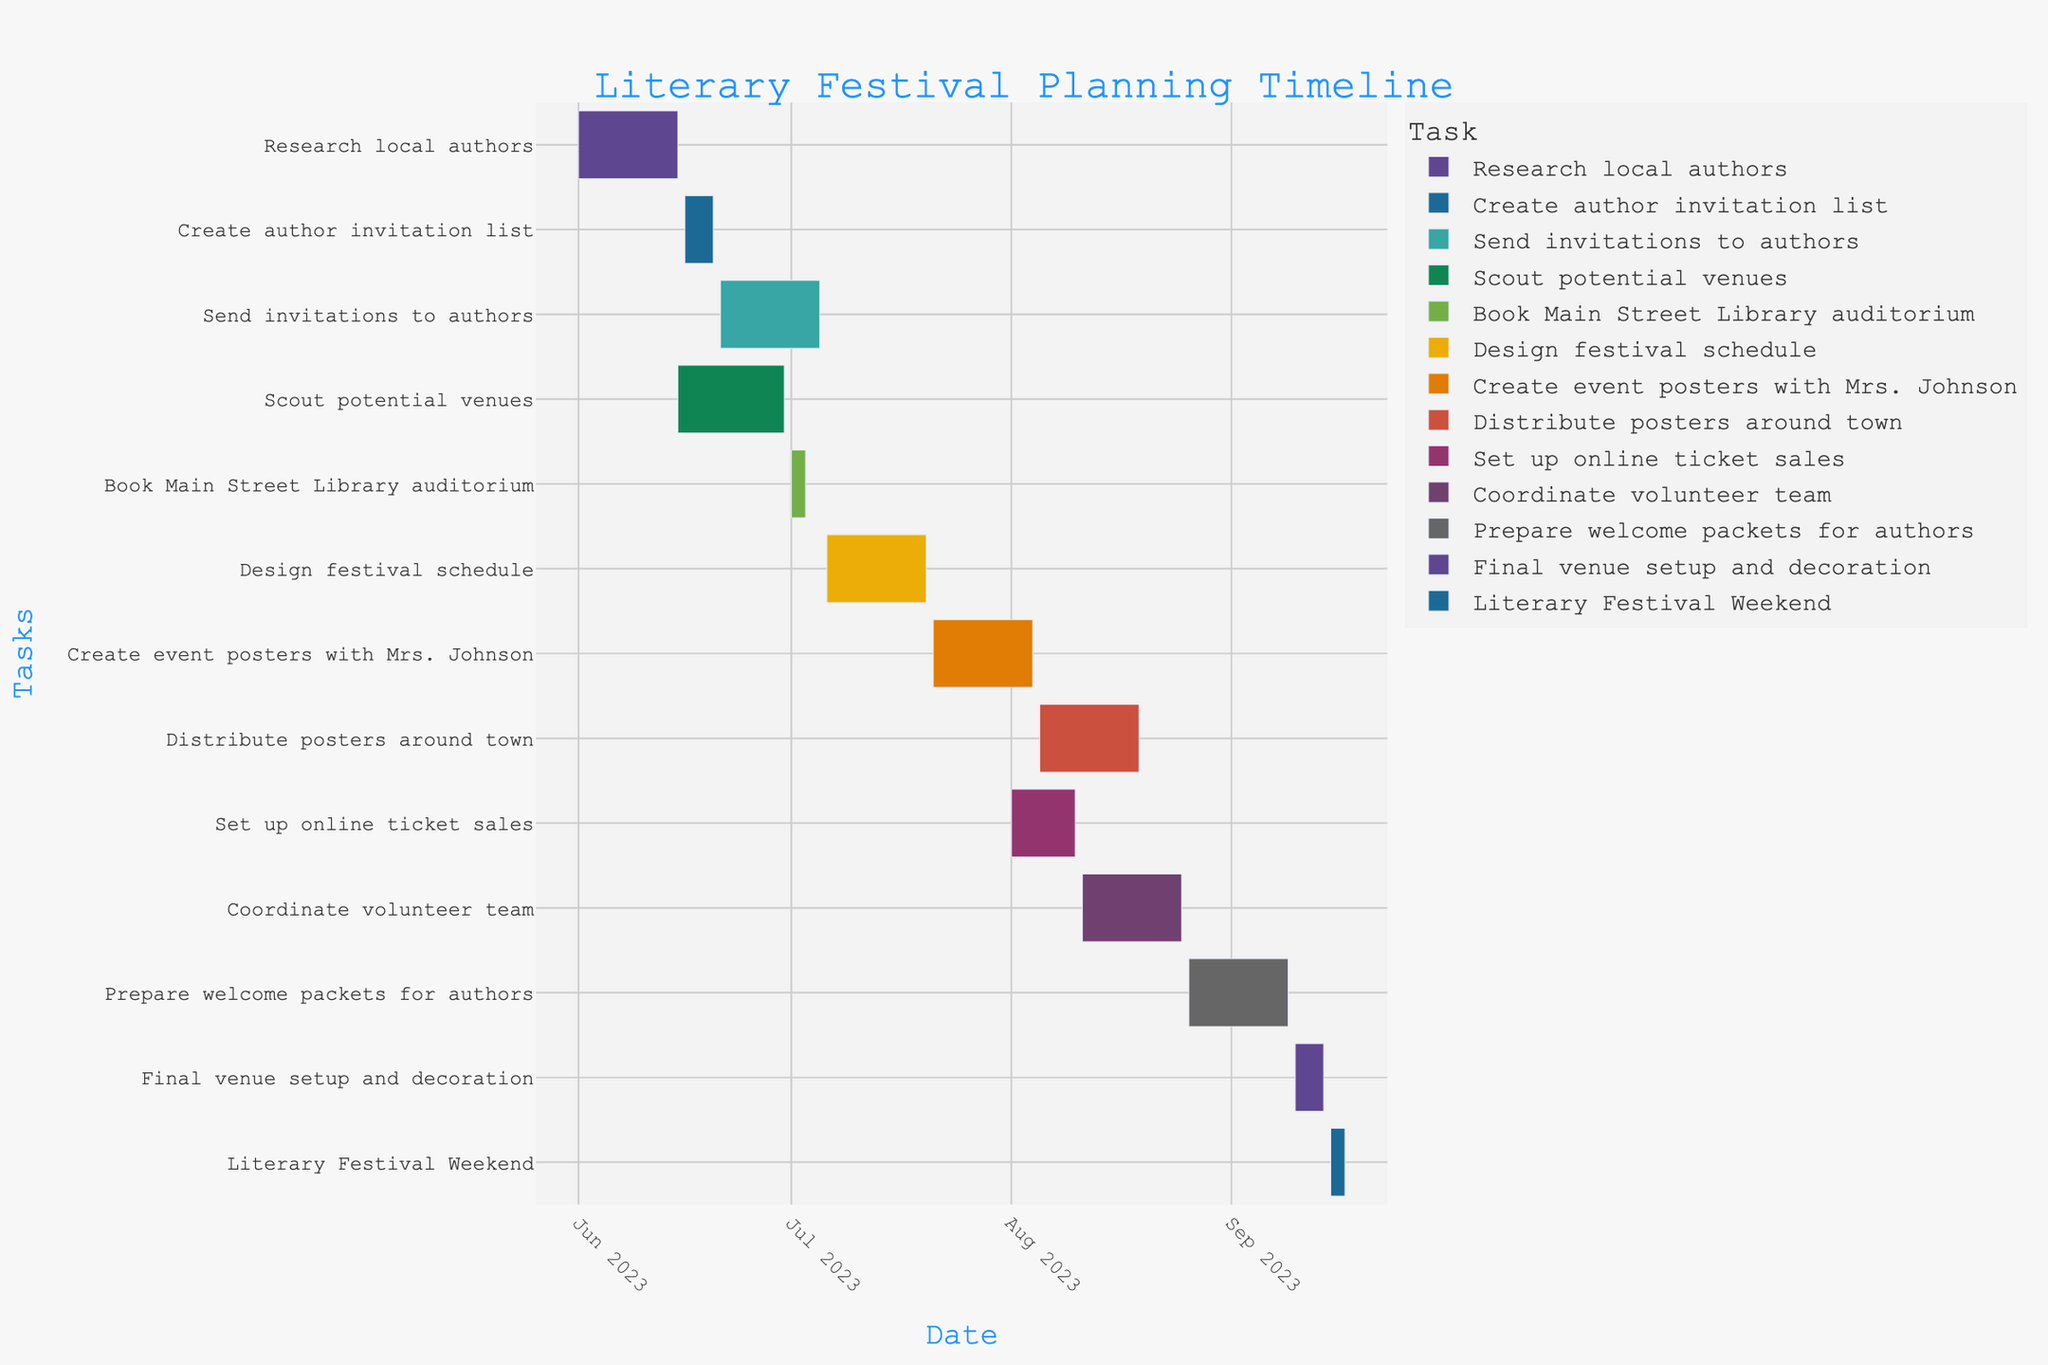What is the title of the chart? The title is usually displayed prominently at the top of the chart. In this case, the title is "Literary Festival Planning Timeline."
Answer: Literary Festival Planning Timeline What are the start and end dates for the "Book Main Street Library auditorium" task? Check the horizontal bars corresponding to the task "Book Main Street Library auditorium." Note the start and end dates next to the bar.
Answer: July 1, 2023 to July 3, 2023 Which task has the longest duration? Compare the length of the bars in the Gantt chart. The task with the longest bar represents the longest duration.
Answer: "Send invitations to authors" How many tasks are scheduled to begin in June 2023? Look for the bars that start in June 2023 and count them.
Answer: Four tasks What tasks are happening in parallel with the "Scout potential venues" task? Identify the time span of the "Scout potential venues" task and look for other bars that overlap with this time span.
Answer: "Research local authors" and "Send invitations to authors" Which task takes place immediately before "Create event posters with Mrs. Johnson"? Find the time span of the "Design festival schedule" task and identify the task that ends just before July 21, 2023.
Answer: "Design festival schedule" What's the average duration of all tasks in the planning timeline? Calculate the duration for each task by subtracting the start date from the end date, sum all durations and divide by the number of tasks.
Answer: Average duration needs calculation based on the provided data, but the process involves summing all durations and dividing by 12 Which task starts the latest in the timeline? Find the task with the latest start date on the x-axis.
Answer: "Final venue setup and decoration" Are any tasks scheduled during the same time as the "Literary Festival Weekend"? Check the dates for "Literary Festival Weekend" and see if any other bars overlap with these dates.
Answer: No tasks overlap with "Literary Festival Weekend" How long is the "Distribute posters around town" task compared to the "Design festival schedule" task? Compare the lengths of the bars for these two tasks to determine which is longer and by how much. "Distribute posters around town" is from August 5 to August 19, and "Design festival schedule" is from July 6 to July 20. Calculate the difference.
Answer: "Distribute posters around town" is 4 days longer than "Design festival schedule" 